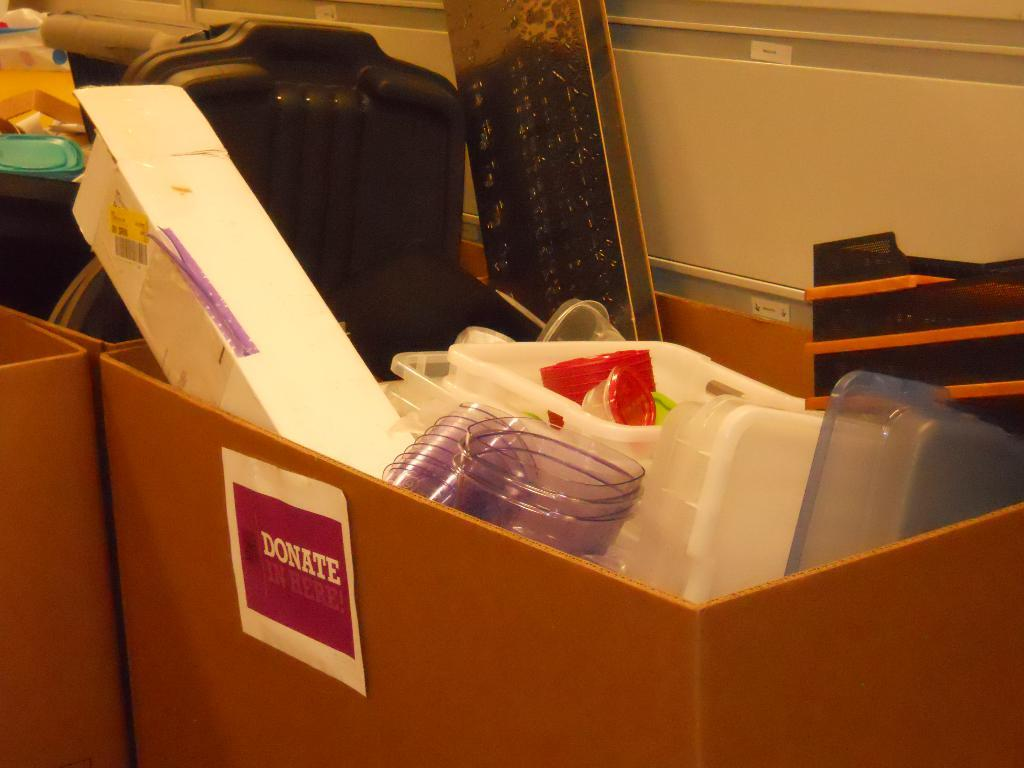What type of containers are inside the carton box? There are plastic boxes and bowls in the carton box. Are there any other carton boxes in the image? Yes, there is another carton box on the side. What can be seen on the left side of the image? There are items visible on the left side. How does the rain affect the items inside the carton box? There is no rain present in the image, so its effect on the items cannot be determined. 